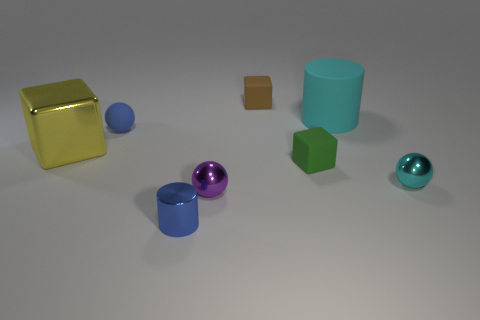Add 2 large brown objects. How many objects exist? 10 Subtract all cubes. How many objects are left? 5 Add 3 tiny green matte cubes. How many tiny green matte cubes exist? 4 Subtract 1 brown cubes. How many objects are left? 7 Subtract all blocks. Subtract all tiny green matte things. How many objects are left? 4 Add 3 big cyan cylinders. How many big cyan cylinders are left? 4 